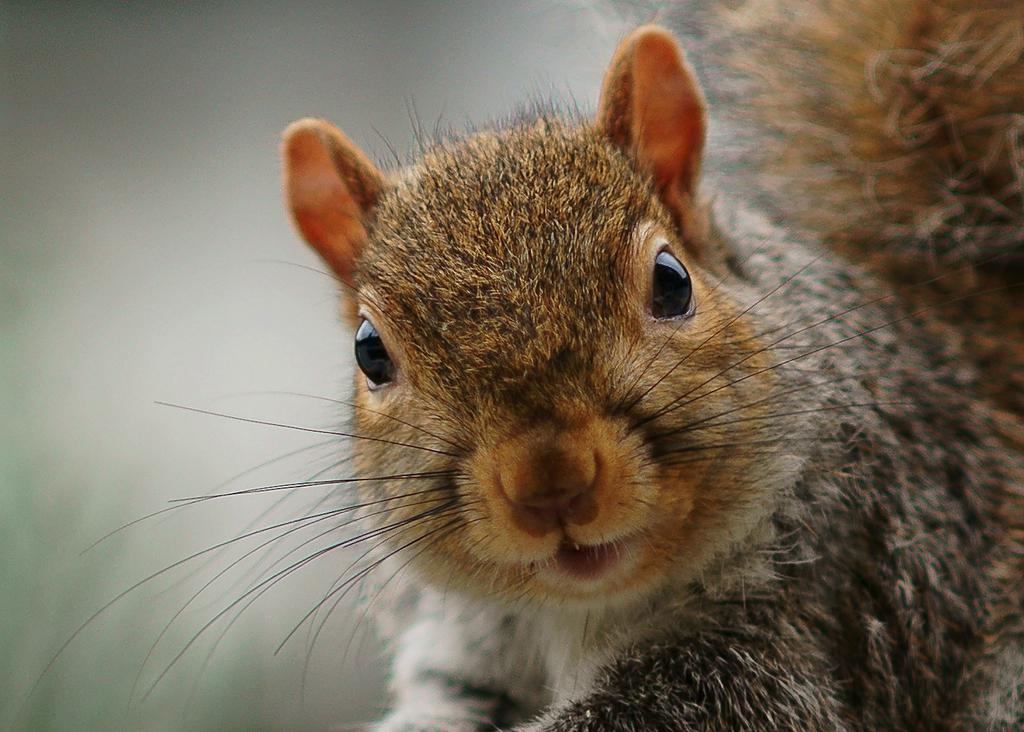Describe this image in one or two sentences. In this picture we can see fox squirrel. On the top left corner we can see darkness. 